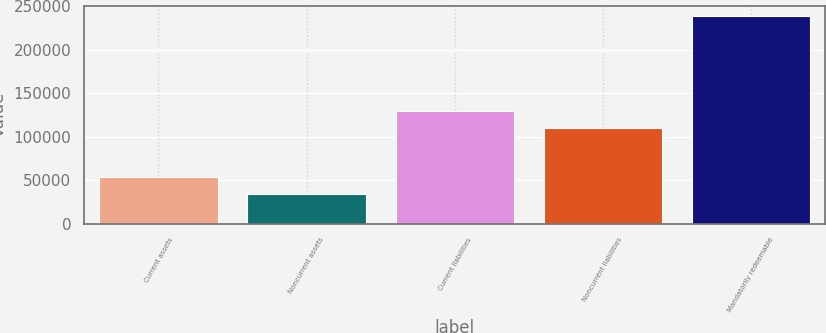Convert chart to OTSL. <chart><loc_0><loc_0><loc_500><loc_500><bar_chart><fcel>Current assets<fcel>Noncurrent assets<fcel>Current liabilities<fcel>Noncurrent liabilities<fcel>Mandatorily redeemable<nl><fcel>54049.7<fcel>33567<fcel>129965<fcel>109482<fcel>238394<nl></chart> 